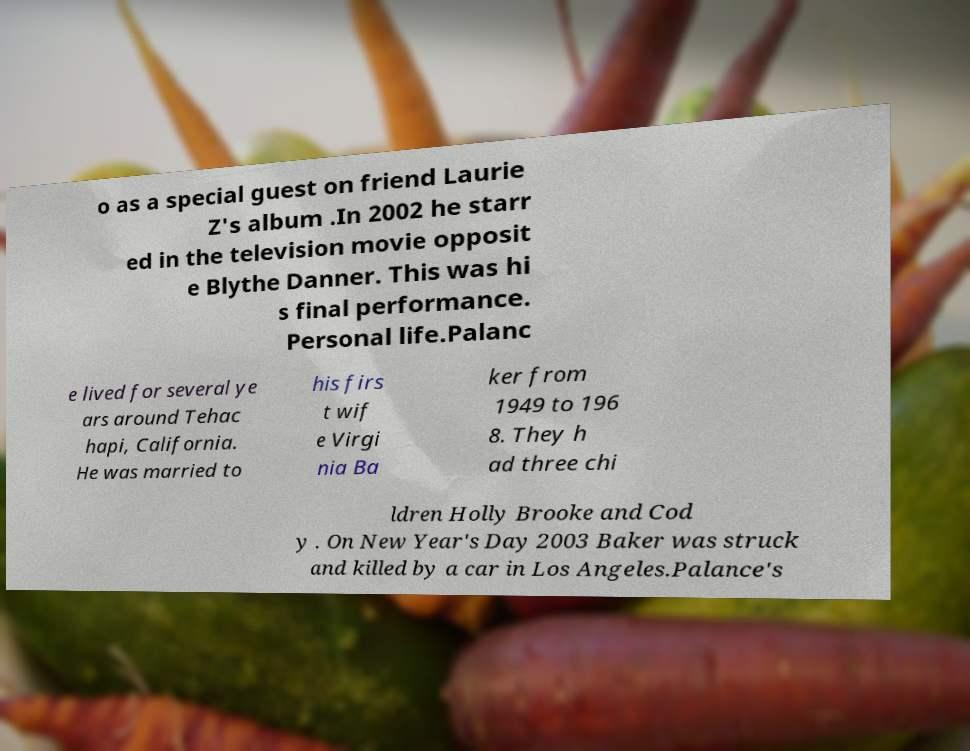For documentation purposes, I need the text within this image transcribed. Could you provide that? o as a special guest on friend Laurie Z's album .In 2002 he starr ed in the television movie opposit e Blythe Danner. This was hi s final performance. Personal life.Palanc e lived for several ye ars around Tehac hapi, California. He was married to his firs t wif e Virgi nia Ba ker from 1949 to 196 8. They h ad three chi ldren Holly Brooke and Cod y . On New Year's Day 2003 Baker was struck and killed by a car in Los Angeles.Palance's 